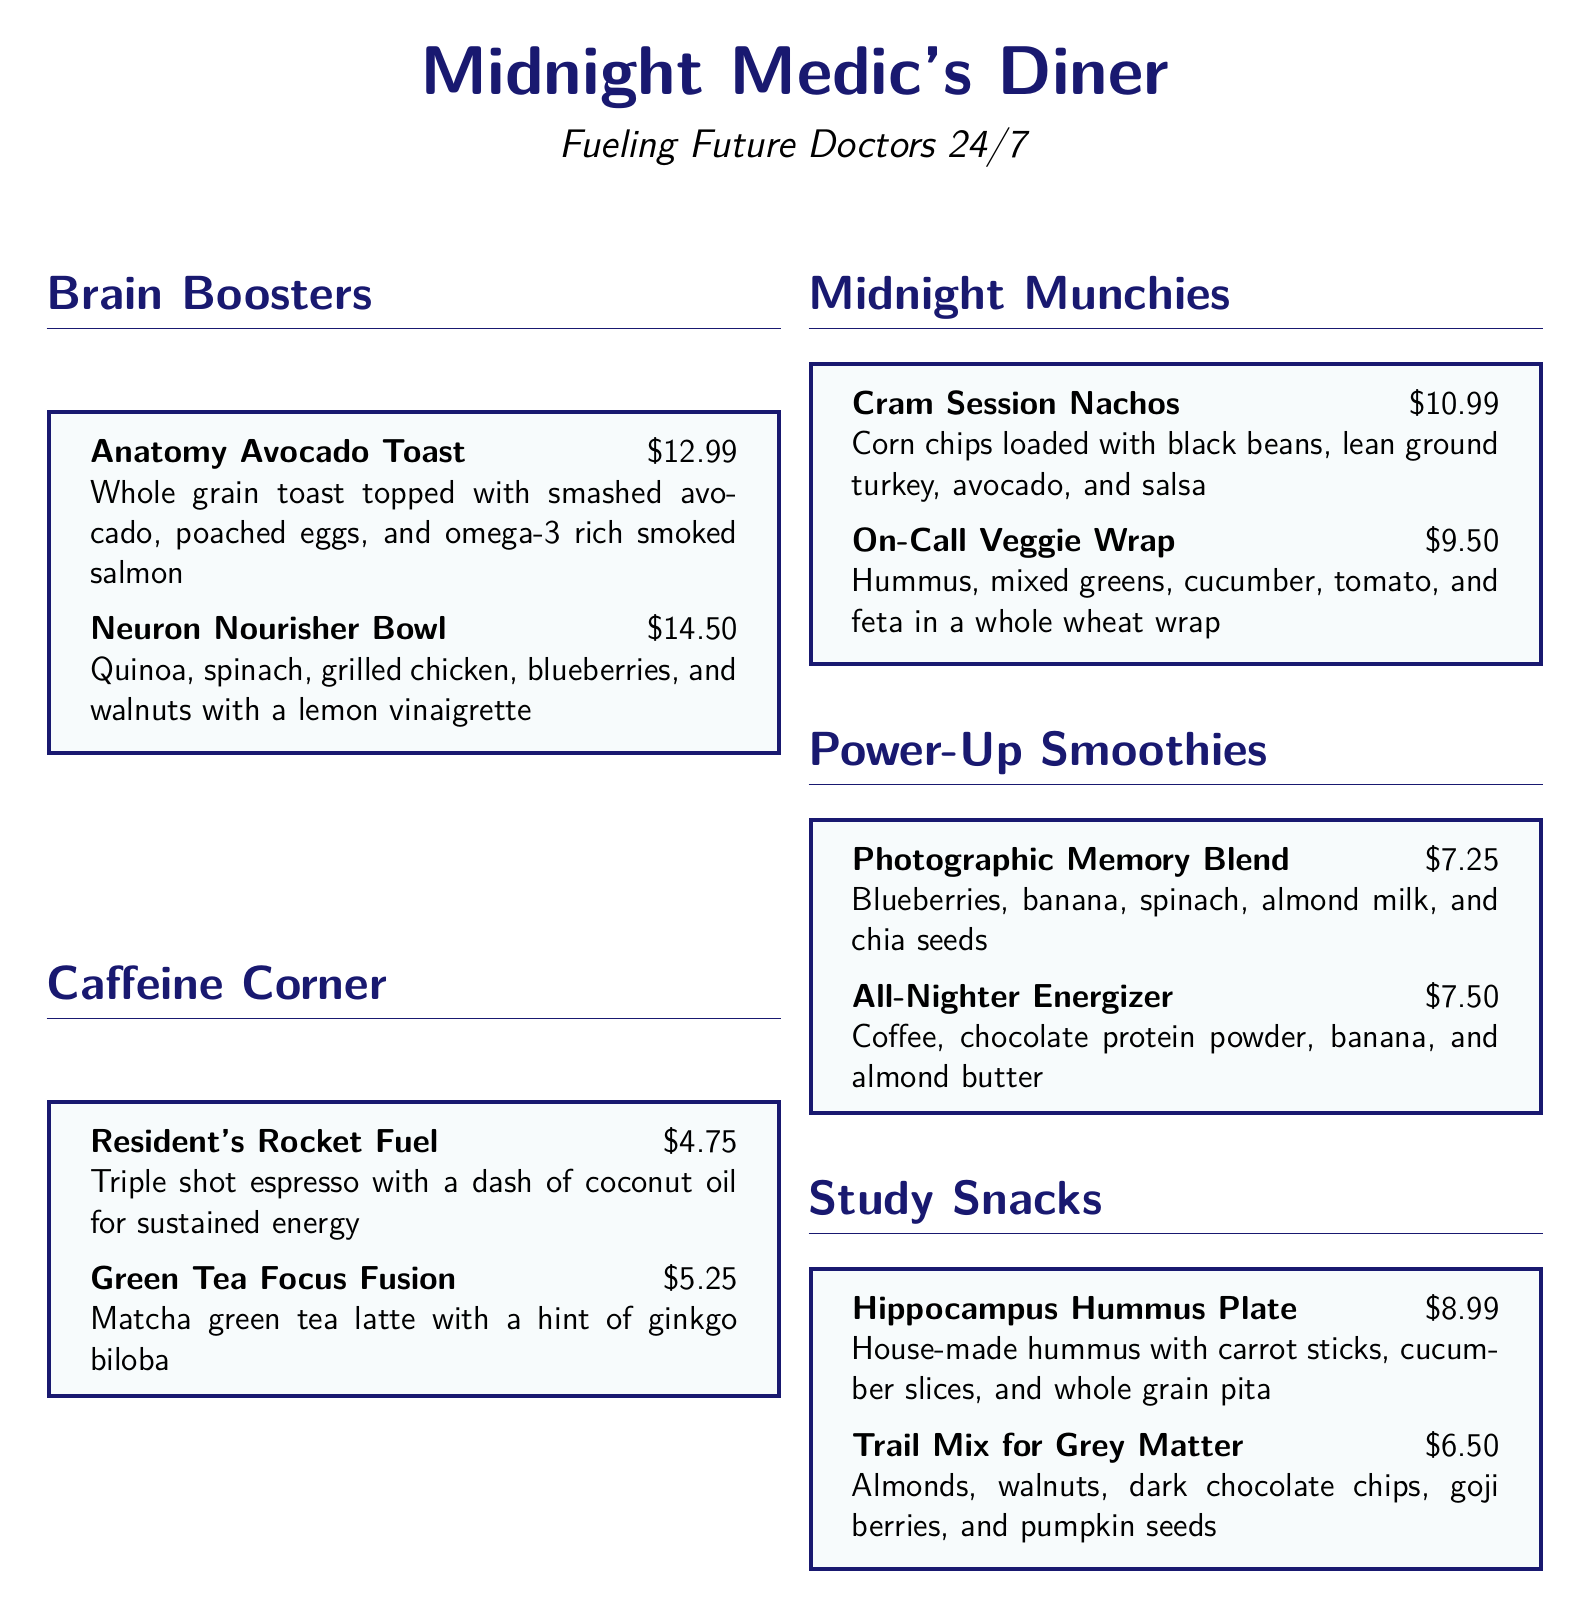What is the name of the diner? The name of the diner is stated at the top of the document, which is "Midnight Medic's Diner."
Answer: Midnight Medic's Diner What is the price of the Neuron Nourisher Bowl? The price of the Neuron Nourisher Bowl is listed next to the dish, which is $14.50.
Answer: $14.50 Which smoothie contains chocolate protein powder? The smoothie that contains chocolate protein powder is mentioned in the menu section under Power-Up Smoothies.
Answer: All-Nighter Energizer How much does the Hippocampus Hummus Plate cost? The cost of the Hippocampus Hummus Plate is directly stated in the menu, which is $8.99.
Answer: $8.99 Which dish includes smoked salmon? The dish that includes smoked salmon is found under the Brain Boosters section of the menu.
Answer: Anatomy Avocado Toast What kind of bread is used in the Anatomy Avocado Toast? The type of bread used in the Anatomy Avocado Toast is mentioned in the description, which is whole grain toast.
Answer: Whole grain What is the largest price on the menu? The largest price can be found by looking at all the prices listed on the menu.
Answer: $14.50 How many items are listed in the Caffeine Corner? The number of items in the Caffeine Corner can be counted from the menu section.
Answer: 2 Which item features goji berries? The item that features goji berries is described in the Study Snacks section of the menu.
Answer: Trail Mix for Grey Matter 